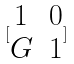<formula> <loc_0><loc_0><loc_500><loc_500>[ \begin{matrix} 1 & 0 \\ G & 1 \end{matrix} ]</formula> 